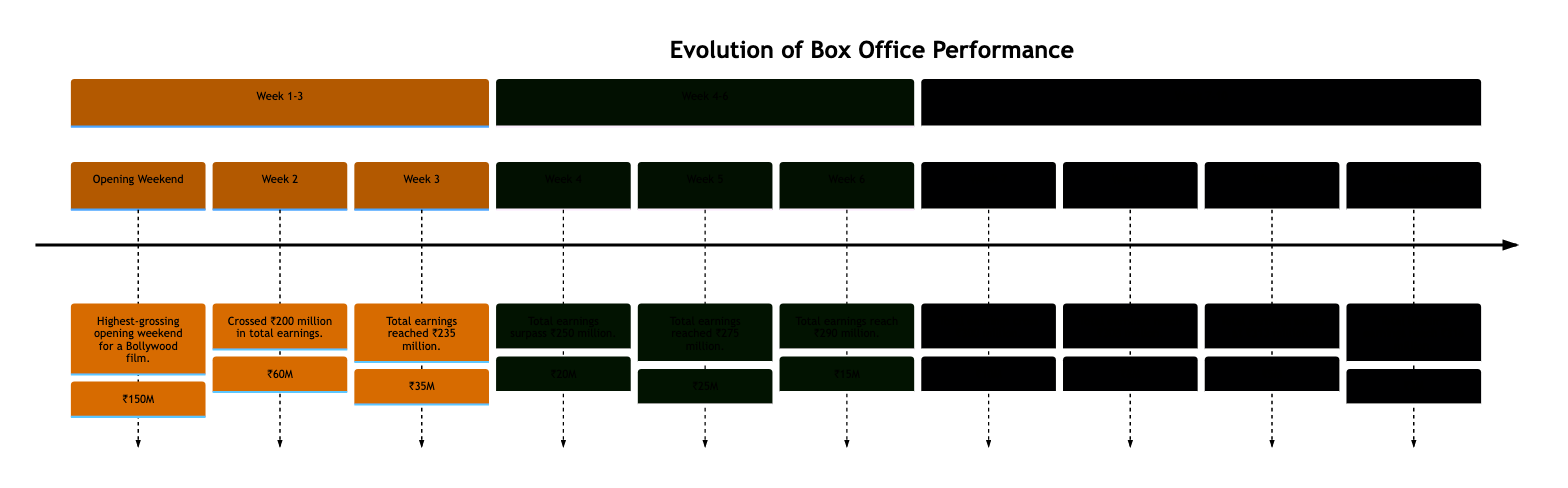What was the box office earnings of Week 1? According to the diagram, Week 1 shows an opening weekend earning of ₹150 million.
Answer: ₹150 million What milestone was achieved in Week 4? The diagram indicates that in Week 4, the total earnings surpassed ₹250 million.
Answer: Surpassed ₹250 million What was the total earnings after Week 5? By the end of Week 5, the diagram shows that total earnings reached ₹275 million.
Answer: ₹275 million How much did the film earn in Week 9? In Week 9, the earnings according to the diagram were ₹5 million.
Answer: ₹5 million What was the box office performance trend from Week 6 to Week 7? From the diagram, it can be concluded that there was a drop in earnings from ₹15 million in Week 6 to ₹10 million in Week 7, indicating a decline in weekly earnings despite crossing ₹300 million in total.
Answer: Decline What is the total earnings after Week 3? The diagram states that by the end of Week 3, total earnings reached ₹235 million, documenting the cumulative success in box office sales at that stage.
Answer: ₹235 million What earnings boost occurred in Week 5? The diagram details that a significant boost in earnings was seen in Week 5 due to a regional festival, which led to a total earnings of ₹275 million.
Answer: Regional festival What was the total lifetime earnings after the final week? According to the diagram, the total lifetime earnings after Week 10 reached ₹316 million, summarizing the film's overall box office success.
Answer: ₹316 million In which week did the film release its digital streaming rights? Week 7 is noted in the diagram as when the release of digital streaming rights occurred, contributing to total earnings crossing ₹300 million.
Answer: Week 7 